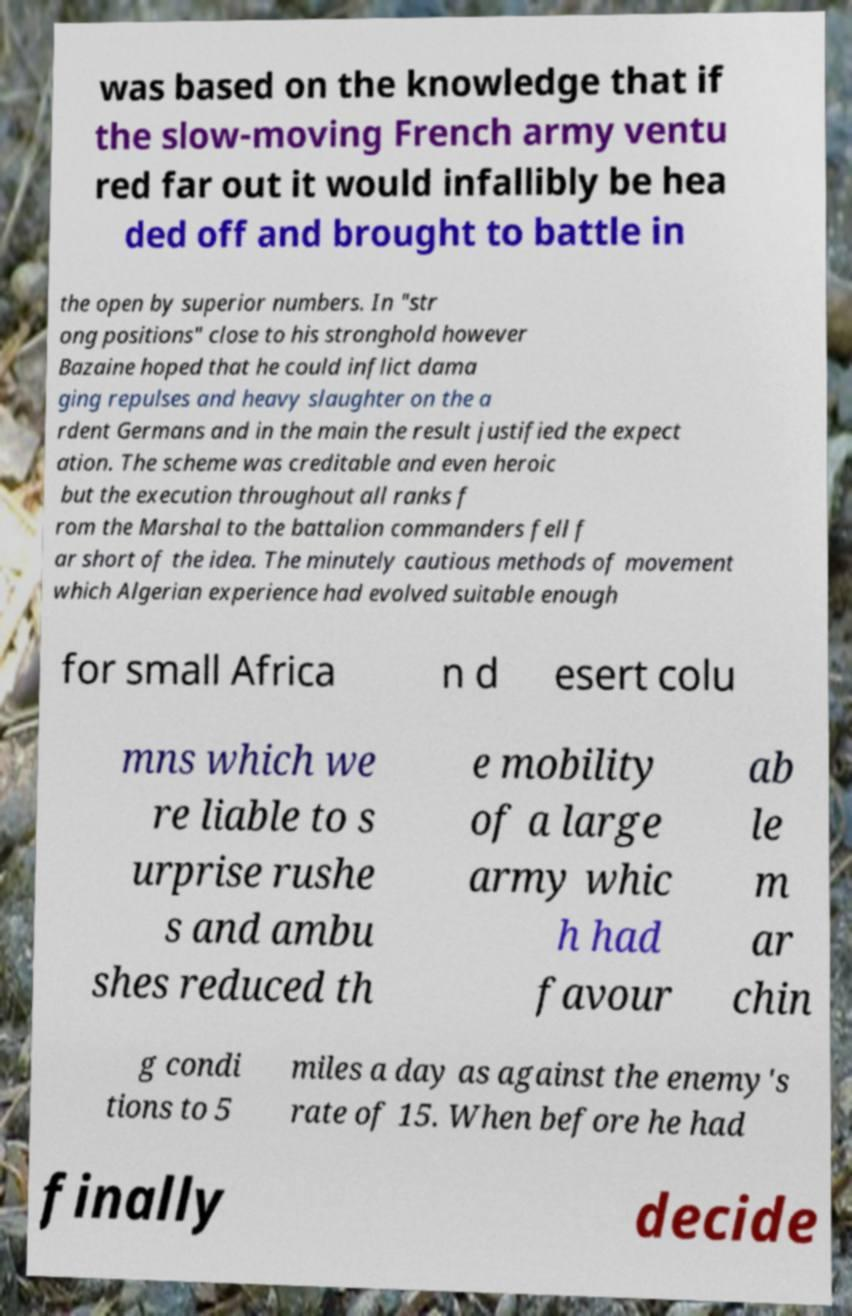Can you accurately transcribe the text from the provided image for me? was based on the knowledge that if the slow-moving French army ventu red far out it would infallibly be hea ded off and brought to battle in the open by superior numbers. In "str ong positions" close to his stronghold however Bazaine hoped that he could inflict dama ging repulses and heavy slaughter on the a rdent Germans and in the main the result justified the expect ation. The scheme was creditable and even heroic but the execution throughout all ranks f rom the Marshal to the battalion commanders fell f ar short of the idea. The minutely cautious methods of movement which Algerian experience had evolved suitable enough for small Africa n d esert colu mns which we re liable to s urprise rushe s and ambu shes reduced th e mobility of a large army whic h had favour ab le m ar chin g condi tions to 5 miles a day as against the enemy's rate of 15. When before he had finally decide 